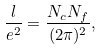<formula> <loc_0><loc_0><loc_500><loc_500>\frac { l } { e ^ { 2 } } = \frac { N _ { c } N _ { f } } { ( 2 \pi ) ^ { 2 } } ,</formula> 